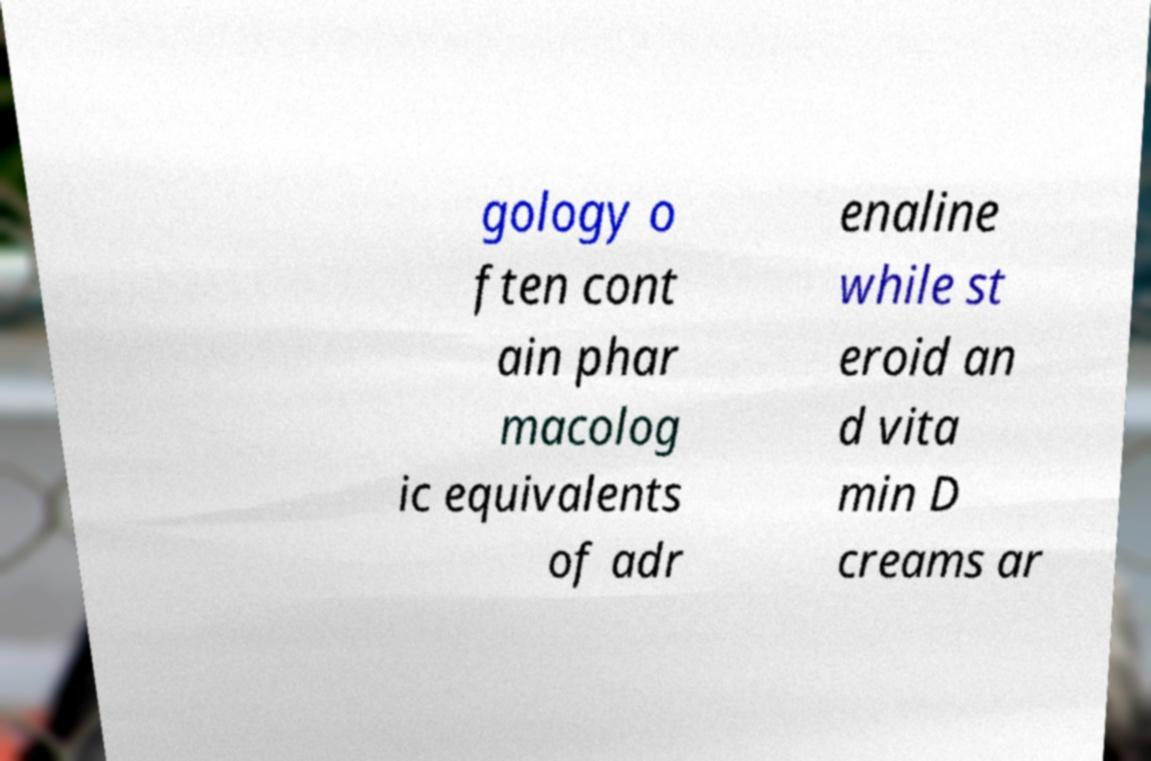I need the written content from this picture converted into text. Can you do that? gology o ften cont ain phar macolog ic equivalents of adr enaline while st eroid an d vita min D creams ar 